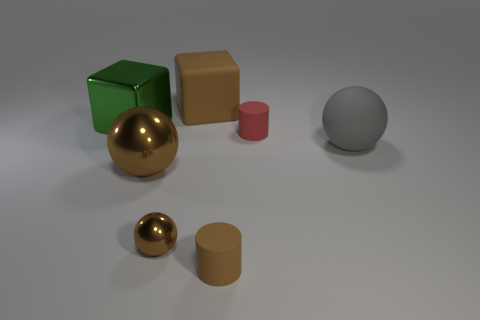Add 1 large gray rubber spheres. How many objects exist? 8 Subtract all cylinders. How many objects are left? 5 Add 2 tiny brown cylinders. How many tiny brown cylinders are left? 3 Add 2 small blue shiny blocks. How many small blue shiny blocks exist? 2 Subtract 0 purple cylinders. How many objects are left? 7 Subtract all gray objects. Subtract all brown spheres. How many objects are left? 4 